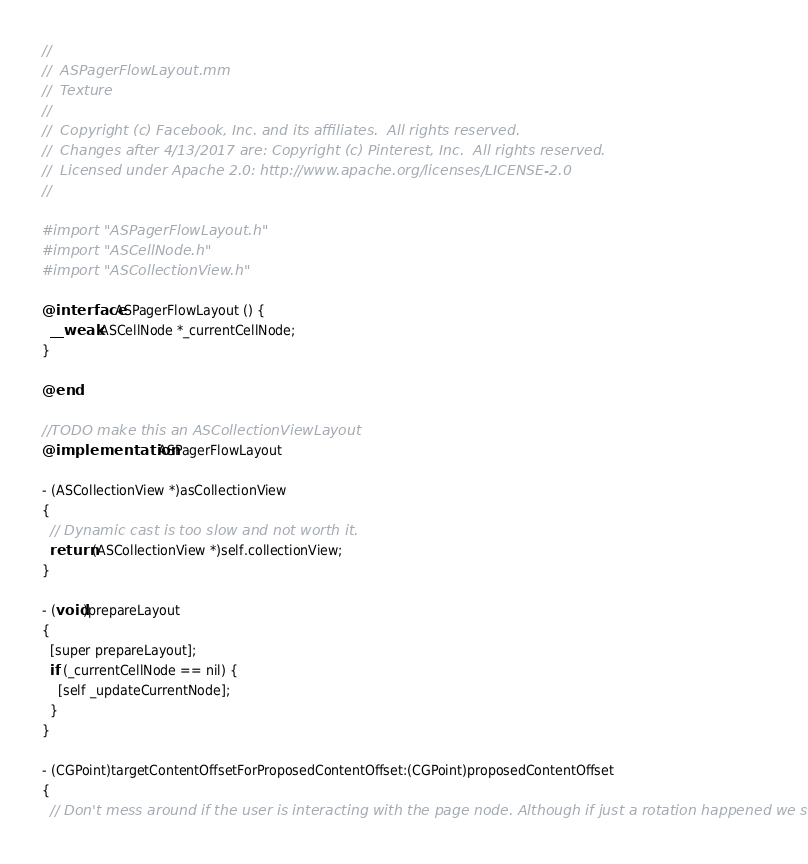<code> <loc_0><loc_0><loc_500><loc_500><_ObjectiveC_>//
//  ASPagerFlowLayout.mm
//  Texture
//
//  Copyright (c) Facebook, Inc. and its affiliates.  All rights reserved.
//  Changes after 4/13/2017 are: Copyright (c) Pinterest, Inc.  All rights reserved.
//  Licensed under Apache 2.0: http://www.apache.org/licenses/LICENSE-2.0
//

#import "ASPagerFlowLayout.h"
#import "ASCellNode.h"
#import "ASCollectionView.h"

@interface ASPagerFlowLayout () {
  __weak ASCellNode *_currentCellNode;
}

@end

//TODO make this an ASCollectionViewLayout
@implementation ASPagerFlowLayout

- (ASCollectionView *)asCollectionView
{
  // Dynamic cast is too slow and not worth it.
  return (ASCollectionView *)self.collectionView;
}

- (void)prepareLayout
{
  [super prepareLayout];
  if (_currentCellNode == nil) {
    [self _updateCurrentNode];
  }
}

- (CGPoint)targetContentOffsetForProposedContentOffset:(CGPoint)proposedContentOffset
{
  // Don't mess around if the user is interacting with the page node. Although if just a rotation happened we should</code> 